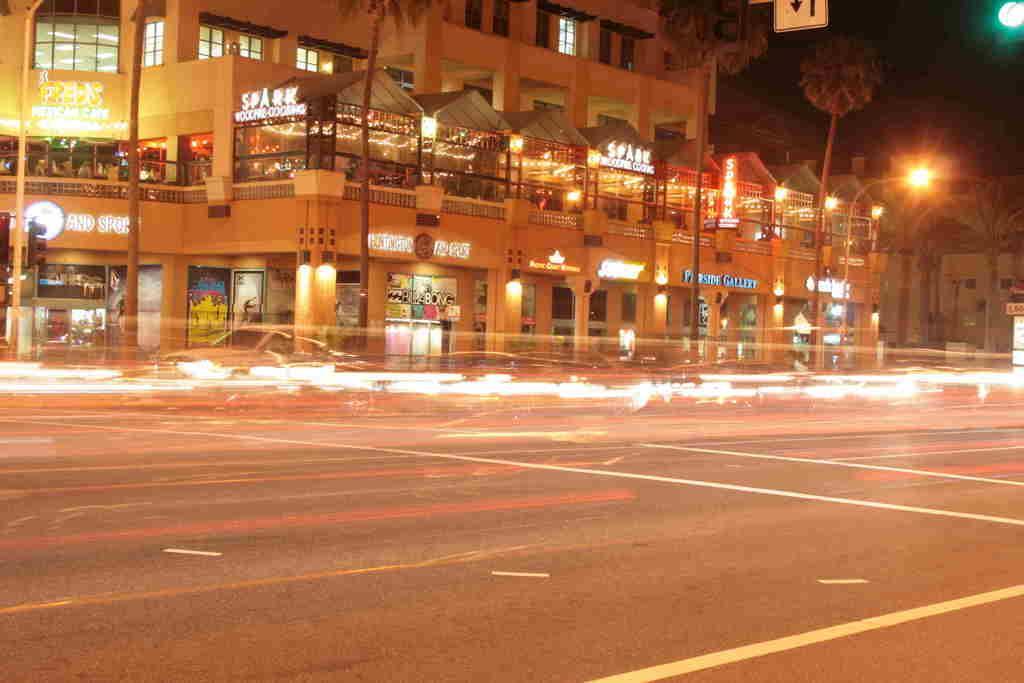Please provide a concise description of this image. This is an outside view in this image in the center there are some buildings, trees, poles, lights and some boards. At the bottom there is a road, and at the top of the image there is sky. 